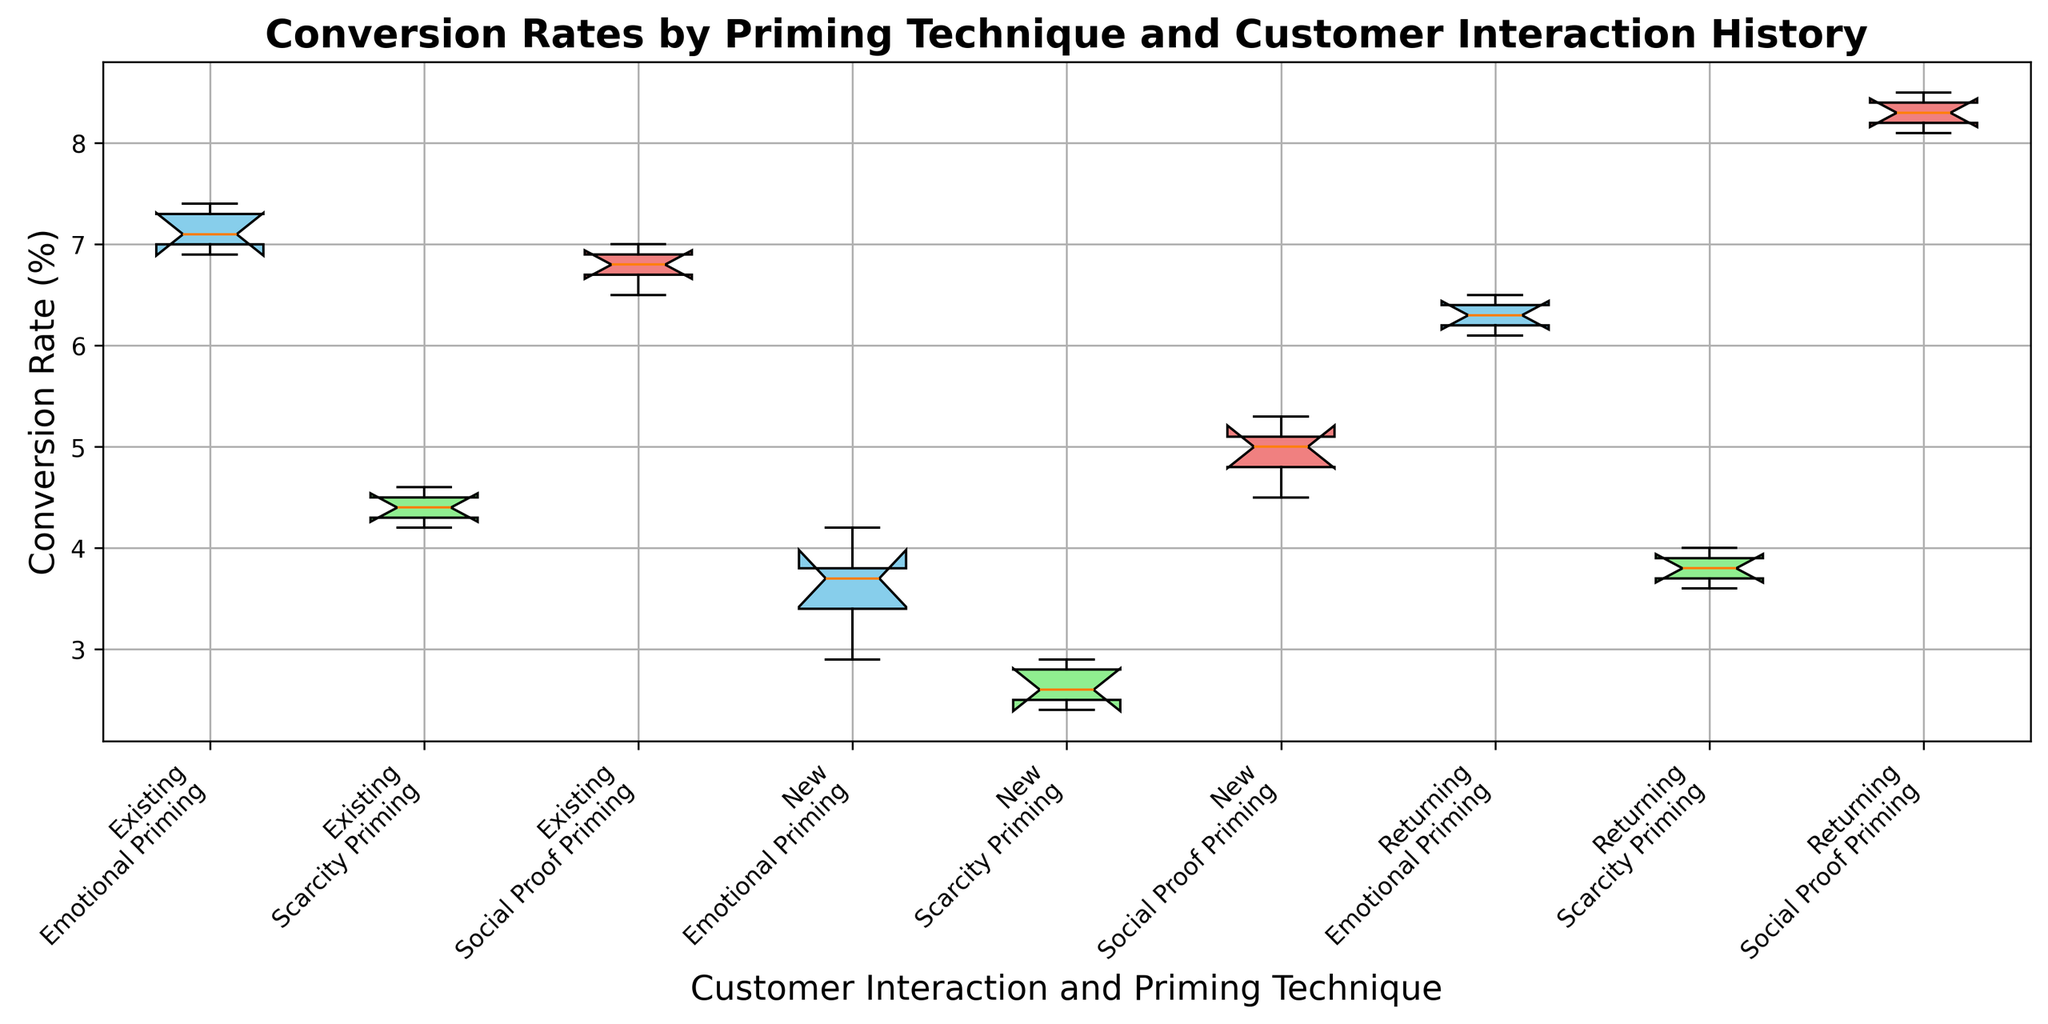What type of priming technique resulted in the highest conversion rates for new customers? Observing the box plot for new customers, Social Proof Priming has higher median and higher quartiles compared to Emotional Priming and Scarcity Priming.
Answer: Social Proof Priming Which customer interaction group showed the largest variability in conversion rates under Emotional Priming? The interquartile range (IQR) is the largest for the "New" customer interaction group as indicated by the span of the box, suggesting higher variability in conversion rates.
Answer: New Comparing previous customer interaction groups, which had the lowest median conversion rate for Scarcity Priming? By looking at the median lines on the box plots for Scarcity Priming across "New," "Existing," and "Returning" groups, the "Returning" group has the lowest median conversion rate.
Answer: Returning How does the median conversion rate for Emotional Priming compare between New and Returning customers? The median for Emotional Priming among Returning customers is higher than the median for New customers, as indicated by the position of the median lines on the box plots.
Answer: Returning > New What is the difference between the highest conversion rate under Social Proof Priming for Returning customers and the highest conversion rate under Scarcity Priming for New customers? The highest conversion rate under Social Proof Priming for Returning customers is around 8.5%, and for Scarcity Priming for New customers is around 2.9%. Therefore, the difference is 8.5% - 2.9% = 5.6%.
Answer: 5.6% For which priming technique do Existing customers have a higher median conversion rate than Returning customers? Comparing the median lines for Existing and Returning customers across all priming techniques, Existing customers show a higher median conversion rate than Returning customers only in Emotional Priming.
Answer: Emotional Priming Which priming technique shows the smallest range in conversion rates for Existing customers? The smallest range, visualized by the length of the whiskers and box in the box plot, is seen in Emotional Priming for Existing customers.
Answer: Emotional Priming What can be inferred about the overall effectiveness of Social Proof Priming compared to Scarcity Priming across all customer interaction groups? Social Proof Priming shows higher medians and overall conversion rates in its box plots across all customer interaction groups compared to Scarcity Priming.
Answer: Social Proof Priming is more effective 